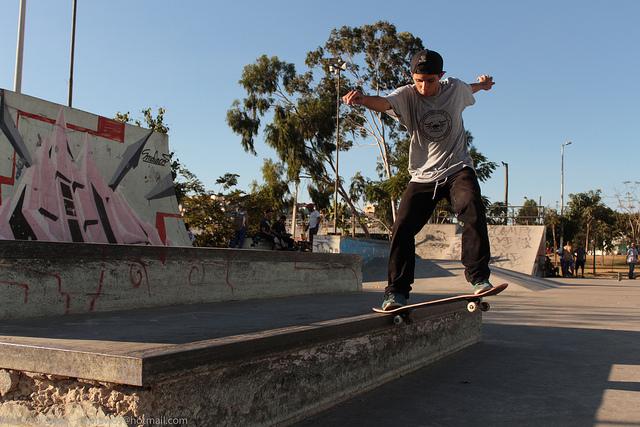Is this a safe way to practice this sport?
Quick response, please. No. What is leaning against the rail?
Short answer required. Skateboard. What is this boy riding on?
Give a very brief answer. Skateboard. Is this person in the air?
Be succinct. Yes. 